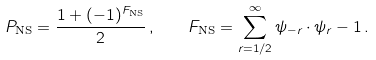<formula> <loc_0><loc_0><loc_500><loc_500>P _ { \text {NS} } = \frac { 1 + ( - 1 ) ^ { F _ { \text {NS} } } } { 2 } \, , \quad F _ { \text {NS} } = \sum _ { r = 1 / 2 } ^ { \infty } \psi _ { - r } \cdot \psi _ { r } - 1 \, .</formula> 